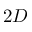<formula> <loc_0><loc_0><loc_500><loc_500>2 D</formula> 